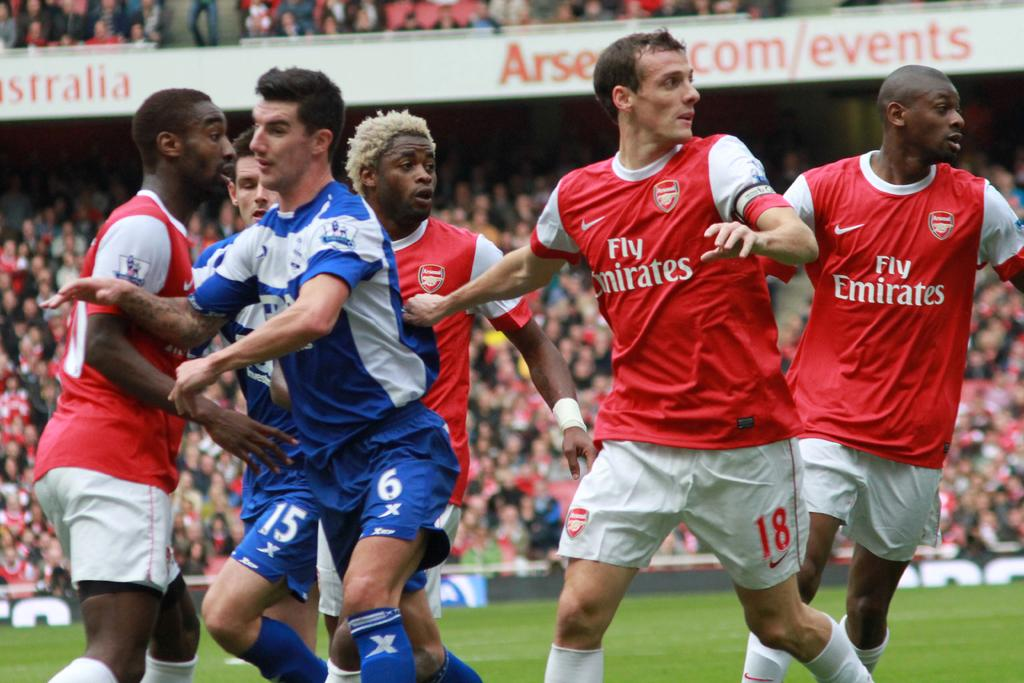<image>
Give a short and clear explanation of the subsequent image. A soccer team sponsored by Emirates playing on a soccer field. 